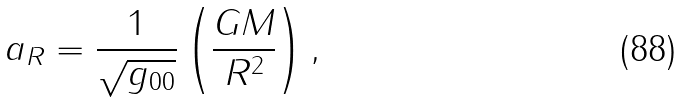Convert formula to latex. <formula><loc_0><loc_0><loc_500><loc_500>a _ { R } = \frac { 1 } { \sqrt { g _ { 0 0 } } } \left ( \frac { G M } { R ^ { 2 } } \right ) ,</formula> 